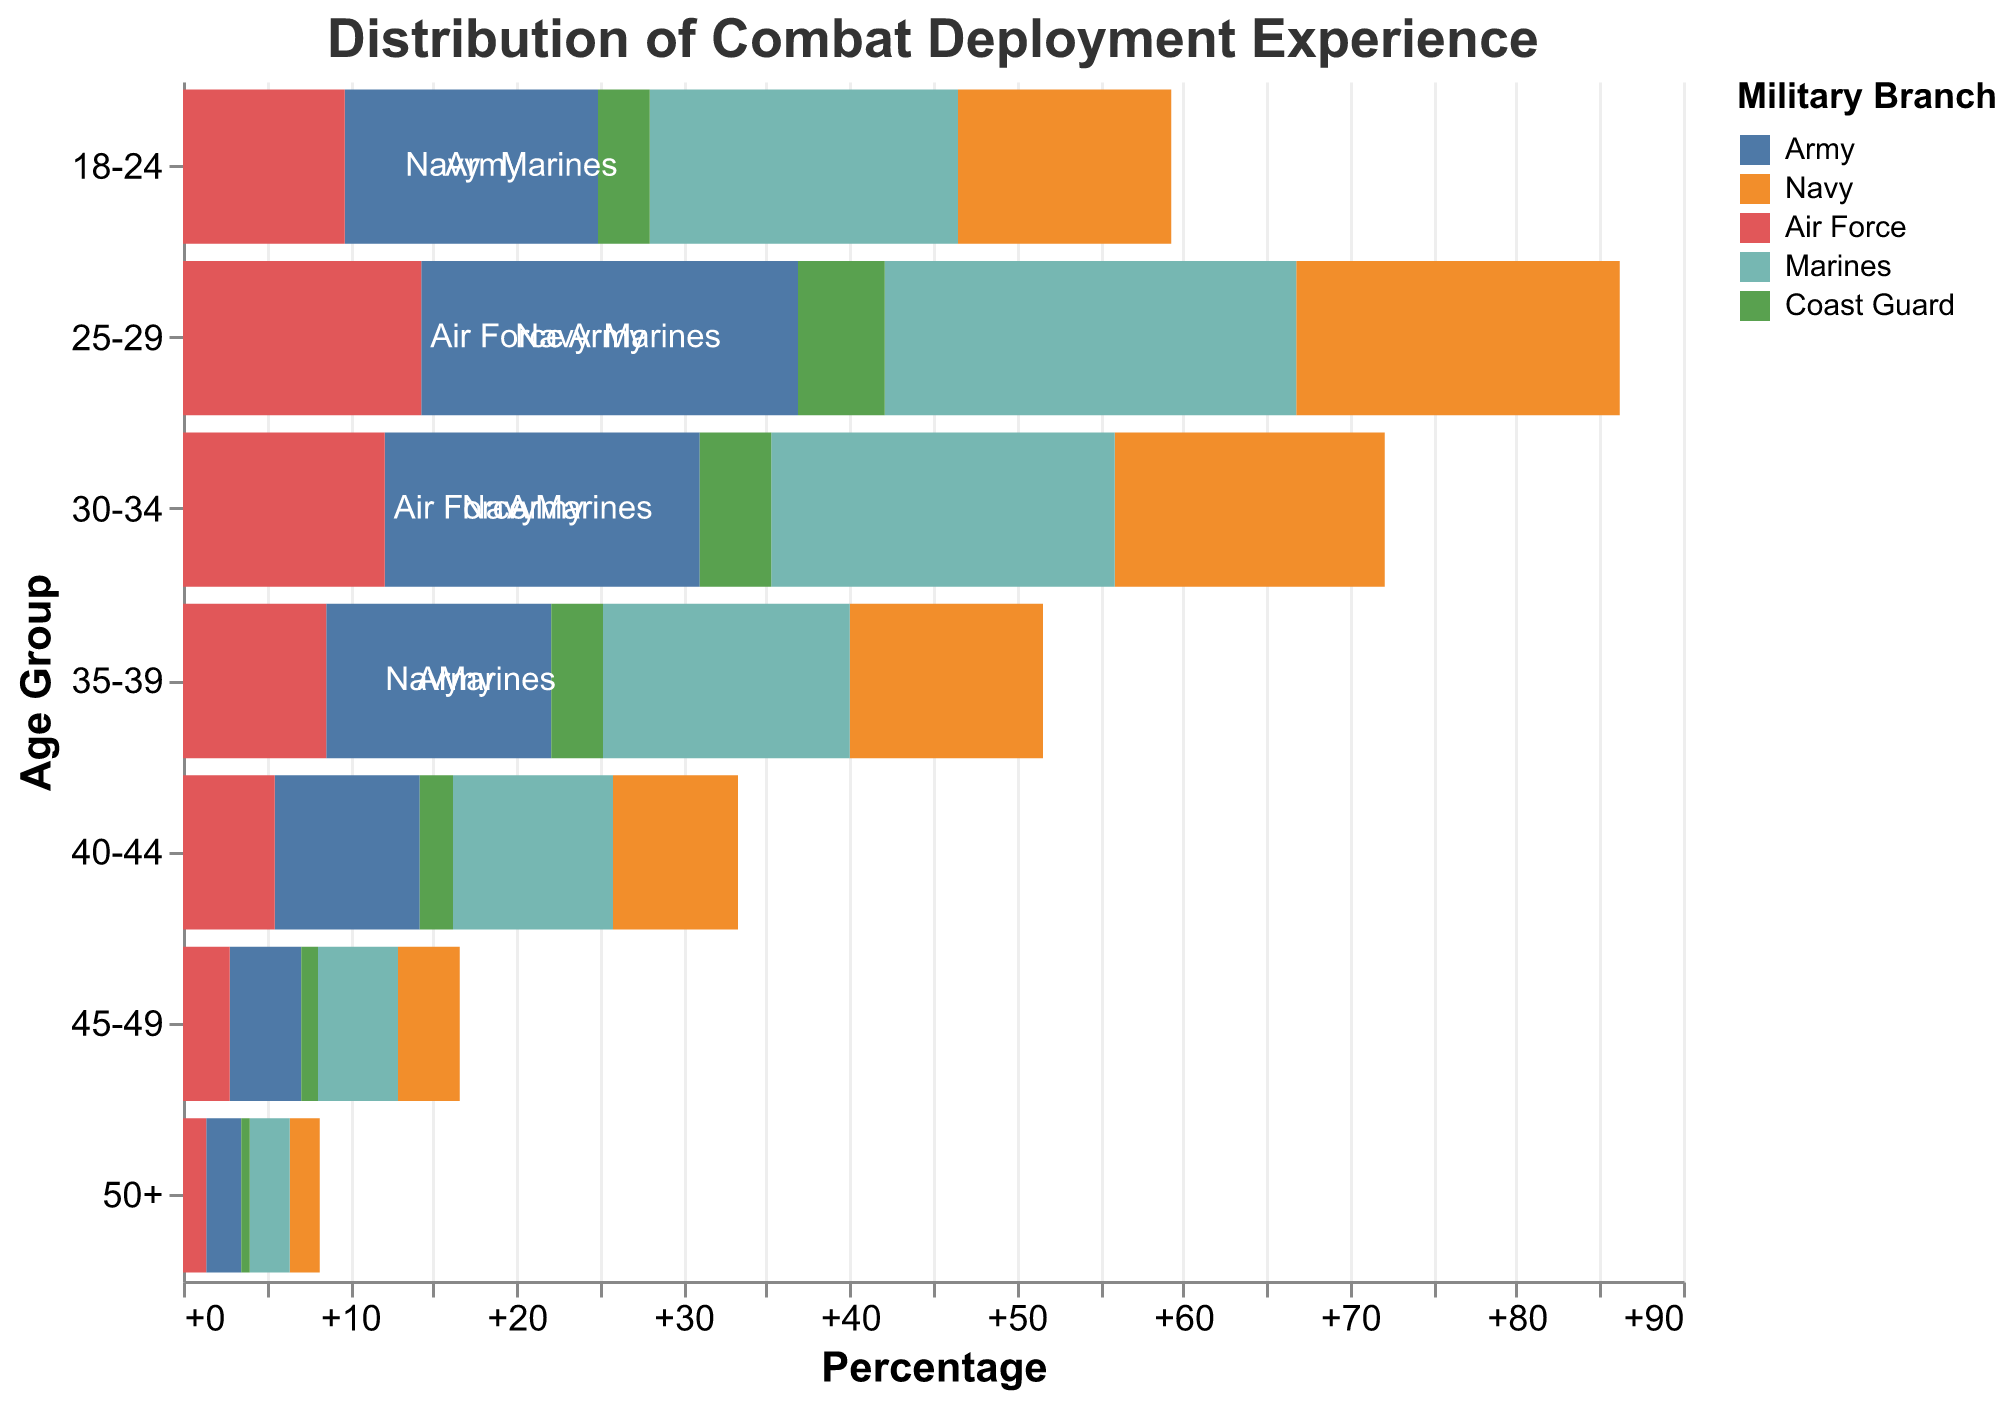How many age groups are shown in the figure? There are data points for each age group on the y-axis. Counting them gives us 7 groups.
Answer: 7 What is the title of the figure? The title is positioned at the top of the figure and states: "Distribution of Combat Deployment Experience".
Answer: Distribution of Combat Deployment Experience Which branch has the highest positive percentage in the 18-24 age group? Observing the values bar for the 18-24 age group, the Marines have the highest positive percentage at 18.5%.
Answer: Marines How does the Army's deployment experience percentage compare between the 25-29 and 40-44 age groups? Comparing the two bars, the Army's percentage is -22.6% for 25-29 and -8.7% for 40-44. The Army has a higher negative percentage (more deployment) in the 25-29 group than in the 40-44 group.
Answer: 25-29 group has more deployment In which age group does the Air Force have the lowest percentage of combat deployment experience? Looking at the Air Force's percentages across all age groups, the lowest is in the 50+ age group at -1.4%.
Answer: 50+ What is the total percentage of combat deployment experience for the Navy across all age groups? Adding up the percentages for each age group for the Navy: 12.8 + 19.4 + 16.2 + 11.6 + 7.5 + 3.7 + 1.8 = 73
Answer: 73 What is the difference in combat deployment experience between the Army and Marines in the 30-34 age group? The values are -18.9% for the Army and 20.6% for the Marines. Calculating the difference: 20.6 - (-18.9) = 39.5.
Answer: 39.5 Which branch consistently has the lowest percentages across all age groups? Observing all data points, the Coast Guard has the consistently lowest percentages in all age groups.
Answer: Coast Guard How does the distribution of combat deployment experience change with age for the Navy? By examining the upward trend in the Navy's positive values from the 18-24 age group to the 50+ age group, it shows a gradual decrease from 12.8% to 1.8%.
Answer: Gradual decrease What is the average percentage of combat deployment experience for the Marines across all age groups? Summing the percentages: 18.5 + 24.7 + 20.6 + 14.8 + 9.6 + 4.8 + 2.4 = 95.4, then dividing by 7 (number of groups): 95.4 / 7 ≈ 13.63%.
Answer: ≈ 13.63 